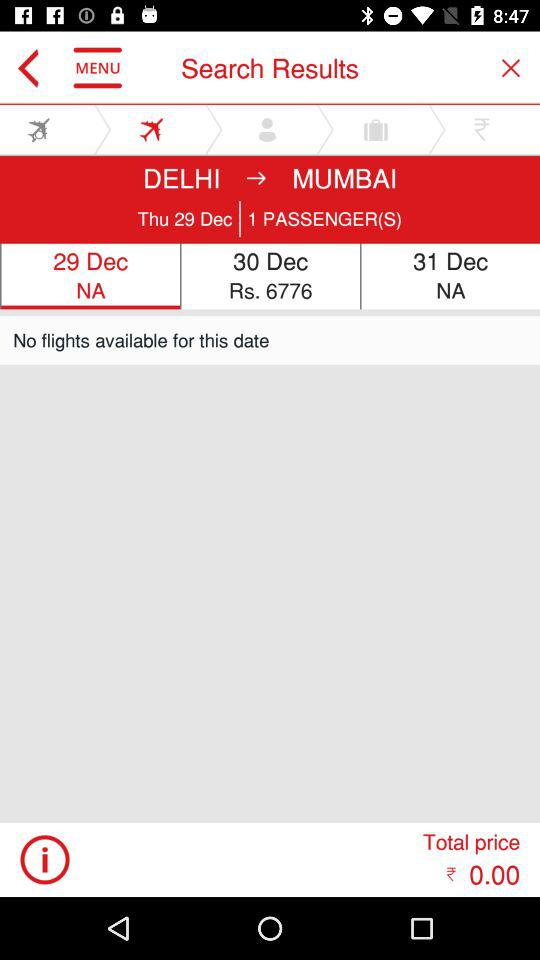What is the flight status on 31 December? The flight status on 31 December is "NA". 